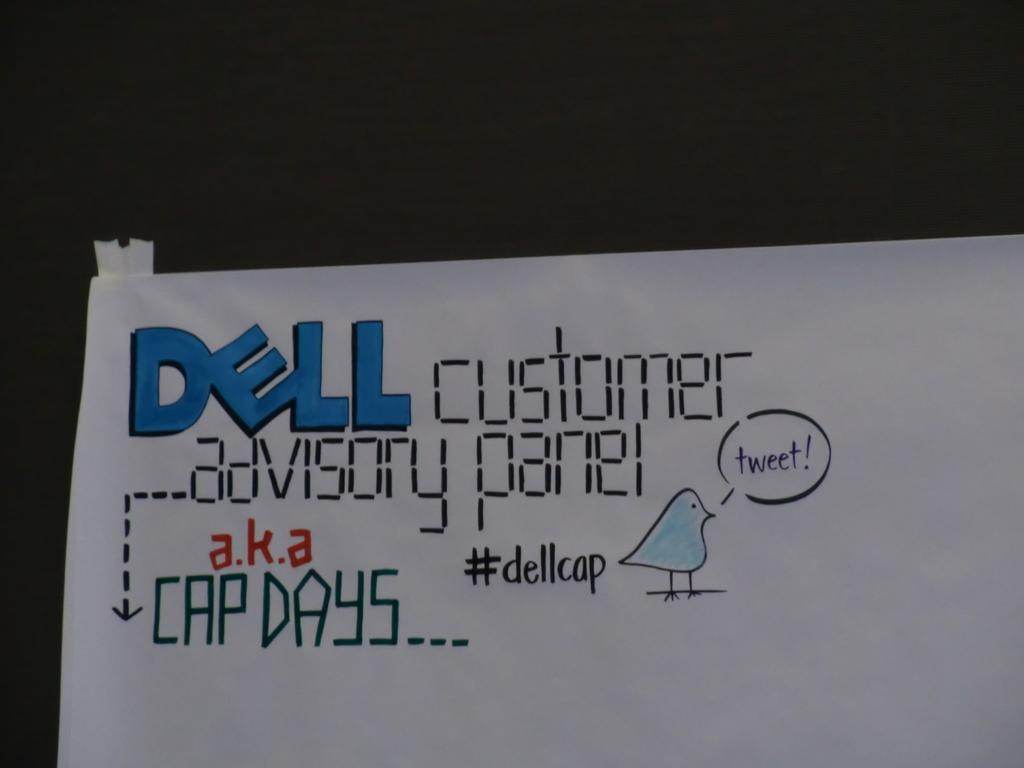What is the main object in the picture? There is a banner in the picture. What can be seen on the banner? The banner has text on it. How would you describe the overall appearance of the image? The background of the image is dark. How many babies are shown on the banner in the image? There are no babies present on the banner or in the image. What type of journey is depicted on the banner? The banner does not depict any journey; it only has text on it. 